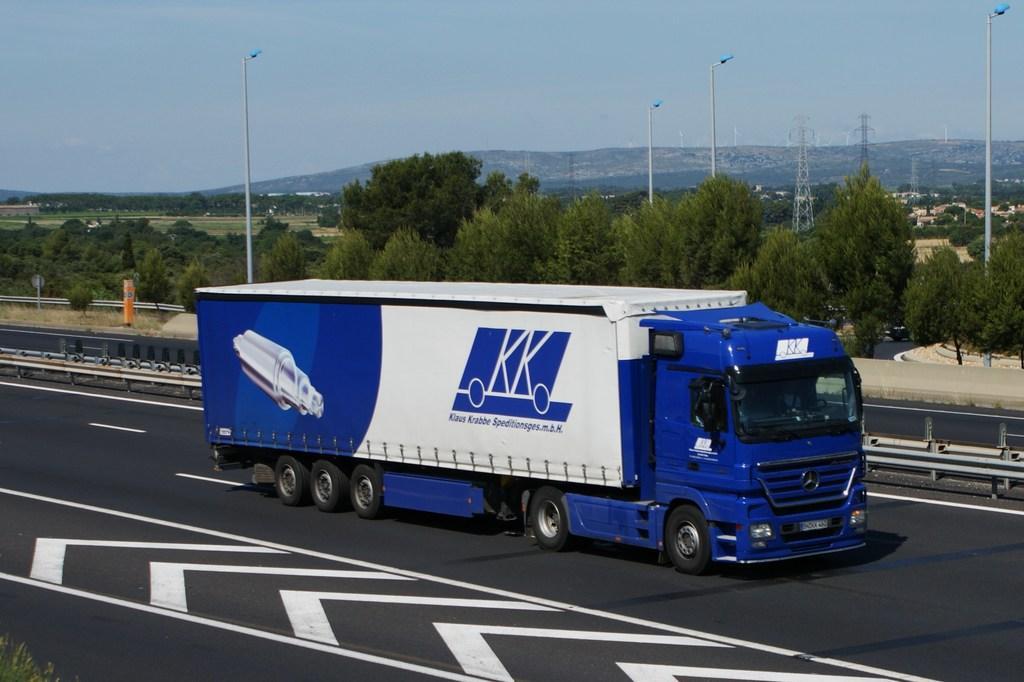Please provide a concise description of this image. In this image, we can see a vehicle. We can see the ground. There are a few trees, towers and poles. We can see the wall. We can also see some hills and houses. We can see some grass and the sky. 